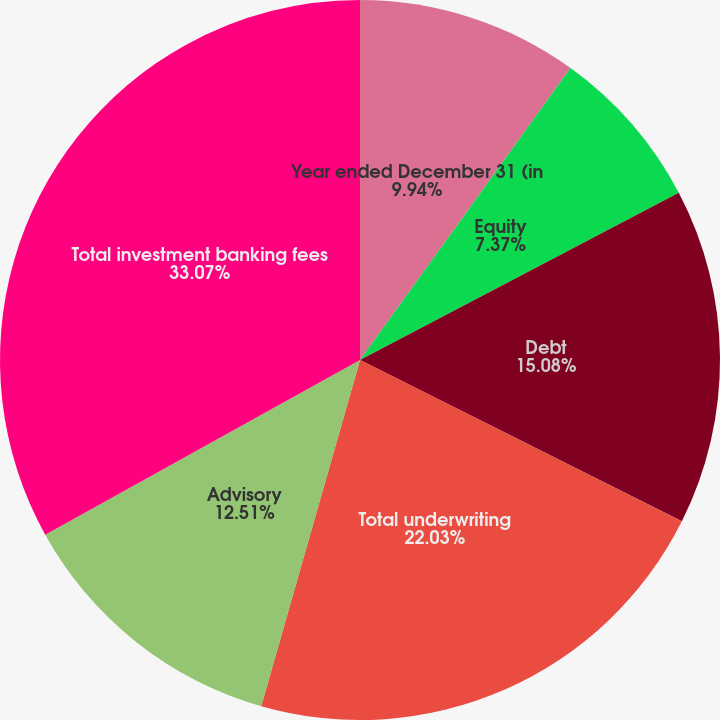<chart> <loc_0><loc_0><loc_500><loc_500><pie_chart><fcel>Year ended December 31 (in<fcel>Equity<fcel>Debt<fcel>Total underwriting<fcel>Advisory<fcel>Total investment banking fees<nl><fcel>9.94%<fcel>7.37%<fcel>15.08%<fcel>22.03%<fcel>12.51%<fcel>33.06%<nl></chart> 